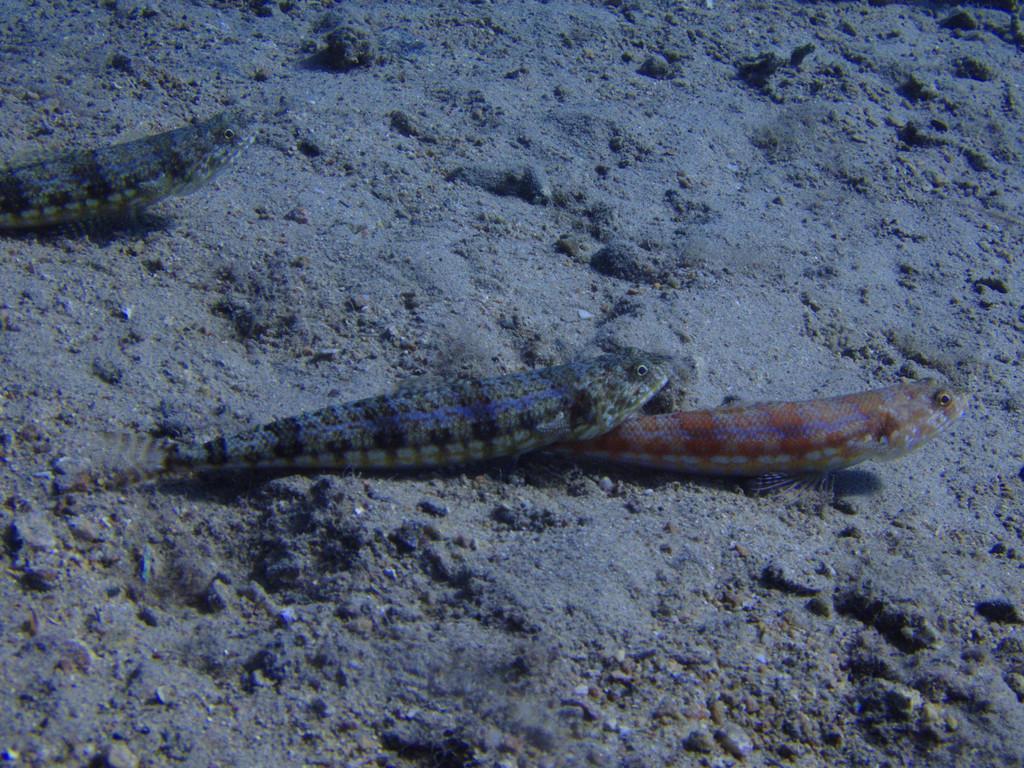Please provide a concise description of this image. In this image, I can see three fishes and stones in the water. This image taken, maybe in the water. 